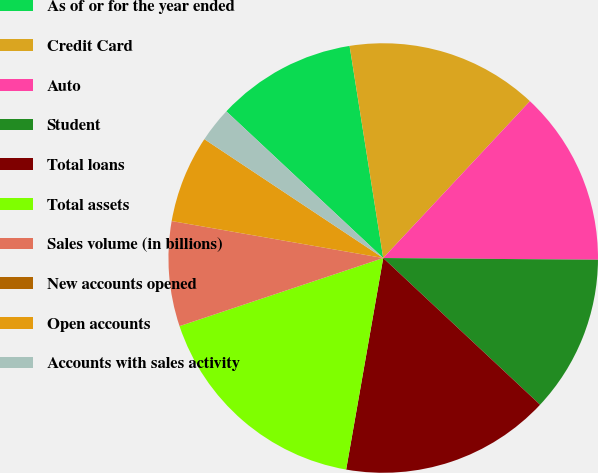<chart> <loc_0><loc_0><loc_500><loc_500><pie_chart><fcel>As of or for the year ended<fcel>Credit Card<fcel>Auto<fcel>Student<fcel>Total loans<fcel>Total assets<fcel>Sales volume (in billions)<fcel>New accounts opened<fcel>Open accounts<fcel>Accounts with sales activity<nl><fcel>10.53%<fcel>14.47%<fcel>13.16%<fcel>11.84%<fcel>15.79%<fcel>17.1%<fcel>7.89%<fcel>0.0%<fcel>6.58%<fcel>2.63%<nl></chart> 